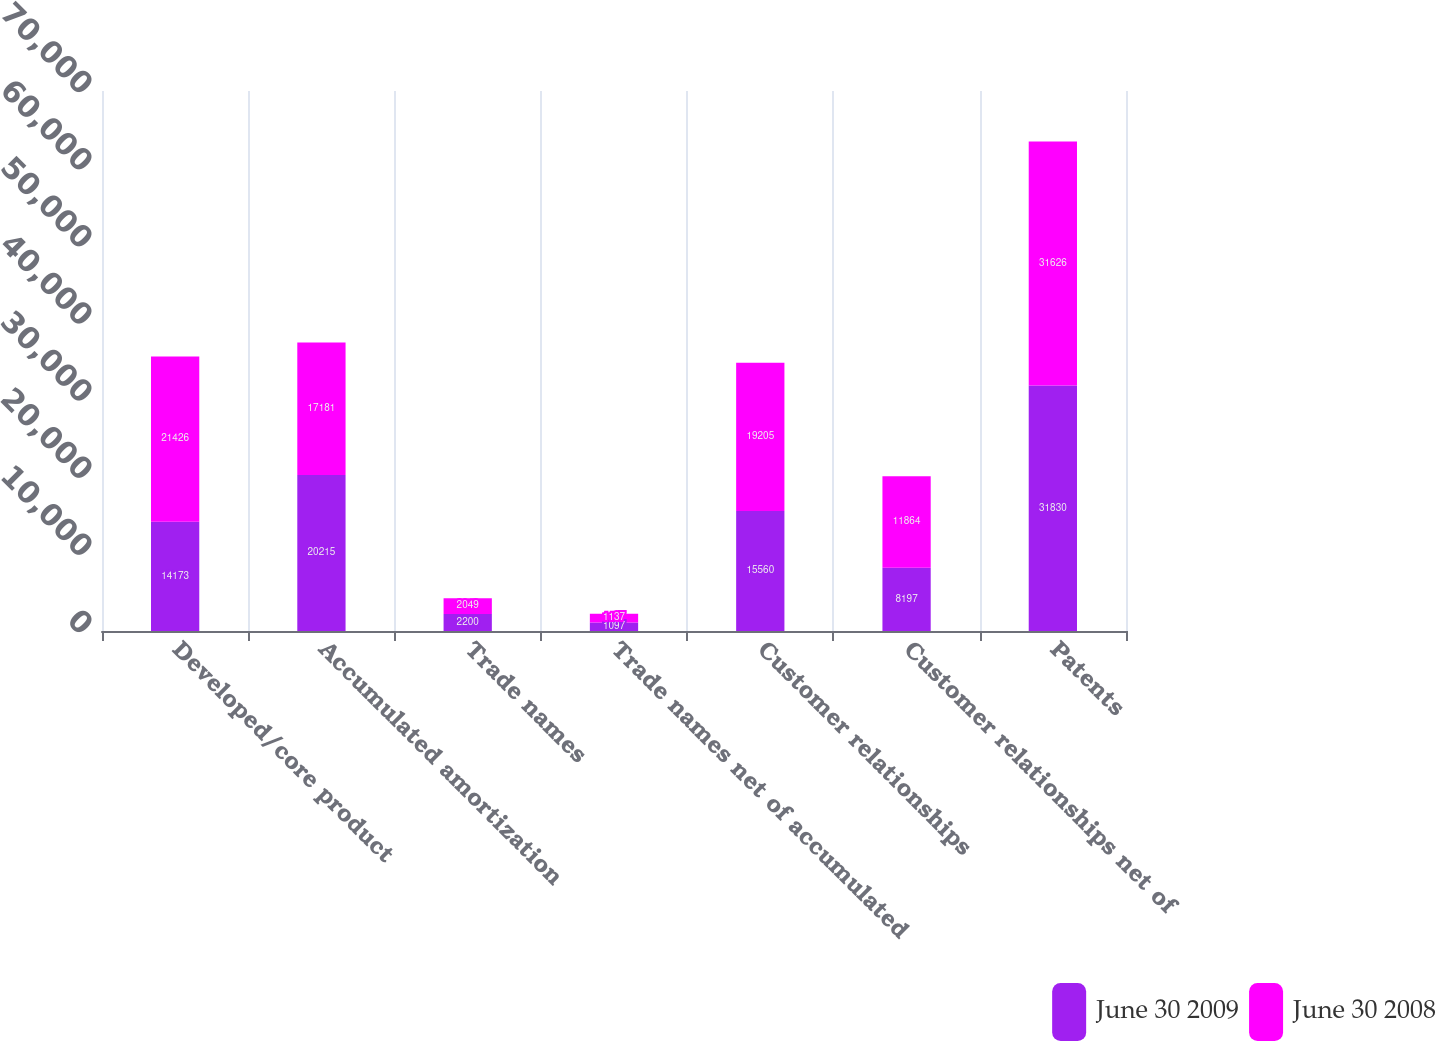Convert chart to OTSL. <chart><loc_0><loc_0><loc_500><loc_500><stacked_bar_chart><ecel><fcel>Developed/core product<fcel>Accumulated amortization<fcel>Trade names<fcel>Trade names net of accumulated<fcel>Customer relationships<fcel>Customer relationships net of<fcel>Patents<nl><fcel>June 30 2009<fcel>14173<fcel>20215<fcel>2200<fcel>1097<fcel>15560<fcel>8197<fcel>31830<nl><fcel>June 30 2008<fcel>21426<fcel>17181<fcel>2049<fcel>1137<fcel>19205<fcel>11864<fcel>31626<nl></chart> 